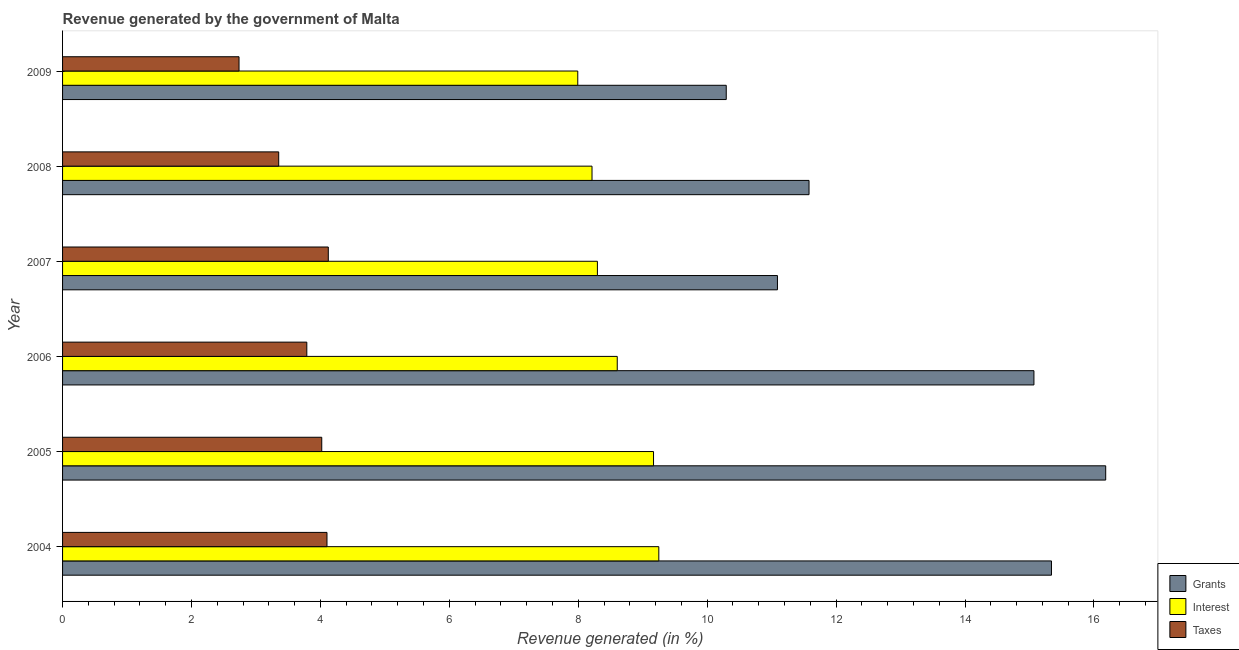How many different coloured bars are there?
Keep it short and to the point. 3. How many groups of bars are there?
Your response must be concise. 6. How many bars are there on the 4th tick from the bottom?
Offer a very short reply. 3. What is the percentage of revenue generated by grants in 2008?
Give a very brief answer. 11.58. Across all years, what is the maximum percentage of revenue generated by grants?
Keep it short and to the point. 16.18. Across all years, what is the minimum percentage of revenue generated by taxes?
Your response must be concise. 2.74. In which year was the percentage of revenue generated by taxes maximum?
Your answer should be compact. 2007. In which year was the percentage of revenue generated by grants minimum?
Your response must be concise. 2009. What is the total percentage of revenue generated by interest in the graph?
Offer a terse response. 51.53. What is the difference between the percentage of revenue generated by interest in 2005 and that in 2006?
Keep it short and to the point. 0.56. What is the difference between the percentage of revenue generated by grants in 2007 and the percentage of revenue generated by taxes in 2004?
Your answer should be compact. 6.99. What is the average percentage of revenue generated by grants per year?
Your answer should be very brief. 13.26. In the year 2006, what is the difference between the percentage of revenue generated by taxes and percentage of revenue generated by interest?
Make the answer very short. -4.82. What is the ratio of the percentage of revenue generated by grants in 2004 to that in 2008?
Your answer should be very brief. 1.32. What is the difference between the highest and the second highest percentage of revenue generated by interest?
Offer a very short reply. 0.08. What is the difference between the highest and the lowest percentage of revenue generated by taxes?
Your answer should be compact. 1.38. In how many years, is the percentage of revenue generated by interest greater than the average percentage of revenue generated by interest taken over all years?
Your response must be concise. 3. Is the sum of the percentage of revenue generated by interest in 2007 and 2008 greater than the maximum percentage of revenue generated by taxes across all years?
Your response must be concise. Yes. What does the 3rd bar from the top in 2005 represents?
Make the answer very short. Grants. What does the 1st bar from the bottom in 2006 represents?
Offer a very short reply. Grants. How many bars are there?
Your response must be concise. 18. Are all the bars in the graph horizontal?
Provide a short and direct response. Yes. Does the graph contain any zero values?
Offer a very short reply. No. What is the title of the graph?
Offer a very short reply. Revenue generated by the government of Malta. Does "Argument" appear as one of the legend labels in the graph?
Your response must be concise. No. What is the label or title of the X-axis?
Ensure brevity in your answer.  Revenue generated (in %). What is the label or title of the Y-axis?
Give a very brief answer. Year. What is the Revenue generated (in %) in Grants in 2004?
Give a very brief answer. 15.34. What is the Revenue generated (in %) of Interest in 2004?
Keep it short and to the point. 9.25. What is the Revenue generated (in %) of Taxes in 2004?
Provide a short and direct response. 4.1. What is the Revenue generated (in %) in Grants in 2005?
Offer a terse response. 16.18. What is the Revenue generated (in %) of Interest in 2005?
Your answer should be compact. 9.17. What is the Revenue generated (in %) of Taxes in 2005?
Offer a very short reply. 4.02. What is the Revenue generated (in %) of Grants in 2006?
Your answer should be compact. 15.07. What is the Revenue generated (in %) of Interest in 2006?
Your response must be concise. 8.6. What is the Revenue generated (in %) of Taxes in 2006?
Your answer should be very brief. 3.79. What is the Revenue generated (in %) of Grants in 2007?
Your response must be concise. 11.09. What is the Revenue generated (in %) in Interest in 2007?
Make the answer very short. 8.3. What is the Revenue generated (in %) in Taxes in 2007?
Keep it short and to the point. 4.12. What is the Revenue generated (in %) of Grants in 2008?
Your response must be concise. 11.58. What is the Revenue generated (in %) of Interest in 2008?
Provide a succinct answer. 8.21. What is the Revenue generated (in %) of Taxes in 2008?
Provide a succinct answer. 3.35. What is the Revenue generated (in %) of Grants in 2009?
Keep it short and to the point. 10.3. What is the Revenue generated (in %) in Interest in 2009?
Make the answer very short. 7.99. What is the Revenue generated (in %) in Taxes in 2009?
Make the answer very short. 2.74. Across all years, what is the maximum Revenue generated (in %) in Grants?
Provide a short and direct response. 16.18. Across all years, what is the maximum Revenue generated (in %) of Interest?
Provide a succinct answer. 9.25. Across all years, what is the maximum Revenue generated (in %) of Taxes?
Ensure brevity in your answer.  4.12. Across all years, what is the minimum Revenue generated (in %) of Grants?
Offer a very short reply. 10.3. Across all years, what is the minimum Revenue generated (in %) of Interest?
Ensure brevity in your answer.  7.99. Across all years, what is the minimum Revenue generated (in %) in Taxes?
Offer a very short reply. 2.74. What is the total Revenue generated (in %) in Grants in the graph?
Offer a very short reply. 79.56. What is the total Revenue generated (in %) in Interest in the graph?
Make the answer very short. 51.53. What is the total Revenue generated (in %) of Taxes in the graph?
Provide a short and direct response. 22.12. What is the difference between the Revenue generated (in %) in Grants in 2004 and that in 2005?
Your response must be concise. -0.84. What is the difference between the Revenue generated (in %) of Interest in 2004 and that in 2005?
Provide a short and direct response. 0.08. What is the difference between the Revenue generated (in %) in Taxes in 2004 and that in 2005?
Your answer should be compact. 0.08. What is the difference between the Revenue generated (in %) in Grants in 2004 and that in 2006?
Provide a succinct answer. 0.27. What is the difference between the Revenue generated (in %) of Interest in 2004 and that in 2006?
Ensure brevity in your answer.  0.64. What is the difference between the Revenue generated (in %) in Taxes in 2004 and that in 2006?
Offer a very short reply. 0.31. What is the difference between the Revenue generated (in %) of Grants in 2004 and that in 2007?
Make the answer very short. 4.25. What is the difference between the Revenue generated (in %) of Interest in 2004 and that in 2007?
Offer a terse response. 0.95. What is the difference between the Revenue generated (in %) of Taxes in 2004 and that in 2007?
Give a very brief answer. -0.02. What is the difference between the Revenue generated (in %) in Grants in 2004 and that in 2008?
Offer a terse response. 3.76. What is the difference between the Revenue generated (in %) of Interest in 2004 and that in 2008?
Your answer should be compact. 1.04. What is the difference between the Revenue generated (in %) of Taxes in 2004 and that in 2008?
Your response must be concise. 0.75. What is the difference between the Revenue generated (in %) of Grants in 2004 and that in 2009?
Provide a short and direct response. 5.05. What is the difference between the Revenue generated (in %) of Interest in 2004 and that in 2009?
Provide a succinct answer. 1.26. What is the difference between the Revenue generated (in %) in Taxes in 2004 and that in 2009?
Make the answer very short. 1.36. What is the difference between the Revenue generated (in %) of Grants in 2005 and that in 2006?
Offer a very short reply. 1.11. What is the difference between the Revenue generated (in %) in Interest in 2005 and that in 2006?
Your answer should be compact. 0.56. What is the difference between the Revenue generated (in %) of Taxes in 2005 and that in 2006?
Keep it short and to the point. 0.23. What is the difference between the Revenue generated (in %) in Grants in 2005 and that in 2007?
Give a very brief answer. 5.09. What is the difference between the Revenue generated (in %) in Interest in 2005 and that in 2007?
Offer a very short reply. 0.87. What is the difference between the Revenue generated (in %) of Taxes in 2005 and that in 2007?
Your response must be concise. -0.1. What is the difference between the Revenue generated (in %) of Grants in 2005 and that in 2008?
Give a very brief answer. 4.6. What is the difference between the Revenue generated (in %) in Interest in 2005 and that in 2008?
Your answer should be compact. 0.95. What is the difference between the Revenue generated (in %) in Taxes in 2005 and that in 2008?
Give a very brief answer. 0.67. What is the difference between the Revenue generated (in %) of Grants in 2005 and that in 2009?
Make the answer very short. 5.89. What is the difference between the Revenue generated (in %) in Interest in 2005 and that in 2009?
Your response must be concise. 1.18. What is the difference between the Revenue generated (in %) in Taxes in 2005 and that in 2009?
Give a very brief answer. 1.28. What is the difference between the Revenue generated (in %) of Grants in 2006 and that in 2007?
Provide a succinct answer. 3.98. What is the difference between the Revenue generated (in %) of Interest in 2006 and that in 2007?
Your answer should be compact. 0.31. What is the difference between the Revenue generated (in %) of Taxes in 2006 and that in 2007?
Give a very brief answer. -0.33. What is the difference between the Revenue generated (in %) in Grants in 2006 and that in 2008?
Ensure brevity in your answer.  3.49. What is the difference between the Revenue generated (in %) in Interest in 2006 and that in 2008?
Your response must be concise. 0.39. What is the difference between the Revenue generated (in %) of Taxes in 2006 and that in 2008?
Provide a succinct answer. 0.44. What is the difference between the Revenue generated (in %) of Grants in 2006 and that in 2009?
Make the answer very short. 4.77. What is the difference between the Revenue generated (in %) in Interest in 2006 and that in 2009?
Make the answer very short. 0.61. What is the difference between the Revenue generated (in %) in Taxes in 2006 and that in 2009?
Keep it short and to the point. 1.05. What is the difference between the Revenue generated (in %) in Grants in 2007 and that in 2008?
Your response must be concise. -0.49. What is the difference between the Revenue generated (in %) in Interest in 2007 and that in 2008?
Provide a succinct answer. 0.08. What is the difference between the Revenue generated (in %) of Taxes in 2007 and that in 2008?
Ensure brevity in your answer.  0.77. What is the difference between the Revenue generated (in %) in Grants in 2007 and that in 2009?
Your response must be concise. 0.79. What is the difference between the Revenue generated (in %) in Interest in 2007 and that in 2009?
Keep it short and to the point. 0.3. What is the difference between the Revenue generated (in %) in Taxes in 2007 and that in 2009?
Make the answer very short. 1.38. What is the difference between the Revenue generated (in %) in Grants in 2008 and that in 2009?
Ensure brevity in your answer.  1.28. What is the difference between the Revenue generated (in %) in Interest in 2008 and that in 2009?
Offer a very short reply. 0.22. What is the difference between the Revenue generated (in %) in Taxes in 2008 and that in 2009?
Make the answer very short. 0.62. What is the difference between the Revenue generated (in %) in Grants in 2004 and the Revenue generated (in %) in Interest in 2005?
Your answer should be very brief. 6.17. What is the difference between the Revenue generated (in %) in Grants in 2004 and the Revenue generated (in %) in Taxes in 2005?
Make the answer very short. 11.32. What is the difference between the Revenue generated (in %) in Interest in 2004 and the Revenue generated (in %) in Taxes in 2005?
Offer a terse response. 5.23. What is the difference between the Revenue generated (in %) in Grants in 2004 and the Revenue generated (in %) in Interest in 2006?
Your answer should be very brief. 6.74. What is the difference between the Revenue generated (in %) of Grants in 2004 and the Revenue generated (in %) of Taxes in 2006?
Make the answer very short. 11.55. What is the difference between the Revenue generated (in %) of Interest in 2004 and the Revenue generated (in %) of Taxes in 2006?
Your answer should be compact. 5.46. What is the difference between the Revenue generated (in %) in Grants in 2004 and the Revenue generated (in %) in Interest in 2007?
Make the answer very short. 7.04. What is the difference between the Revenue generated (in %) of Grants in 2004 and the Revenue generated (in %) of Taxes in 2007?
Your answer should be compact. 11.22. What is the difference between the Revenue generated (in %) of Interest in 2004 and the Revenue generated (in %) of Taxes in 2007?
Provide a succinct answer. 5.13. What is the difference between the Revenue generated (in %) in Grants in 2004 and the Revenue generated (in %) in Interest in 2008?
Offer a very short reply. 7.13. What is the difference between the Revenue generated (in %) in Grants in 2004 and the Revenue generated (in %) in Taxes in 2008?
Offer a very short reply. 11.99. What is the difference between the Revenue generated (in %) of Interest in 2004 and the Revenue generated (in %) of Taxes in 2008?
Provide a short and direct response. 5.9. What is the difference between the Revenue generated (in %) of Grants in 2004 and the Revenue generated (in %) of Interest in 2009?
Your answer should be very brief. 7.35. What is the difference between the Revenue generated (in %) in Grants in 2004 and the Revenue generated (in %) in Taxes in 2009?
Provide a short and direct response. 12.6. What is the difference between the Revenue generated (in %) of Interest in 2004 and the Revenue generated (in %) of Taxes in 2009?
Ensure brevity in your answer.  6.51. What is the difference between the Revenue generated (in %) of Grants in 2005 and the Revenue generated (in %) of Interest in 2006?
Give a very brief answer. 7.58. What is the difference between the Revenue generated (in %) of Grants in 2005 and the Revenue generated (in %) of Taxes in 2006?
Your answer should be very brief. 12.39. What is the difference between the Revenue generated (in %) of Interest in 2005 and the Revenue generated (in %) of Taxes in 2006?
Offer a terse response. 5.38. What is the difference between the Revenue generated (in %) of Grants in 2005 and the Revenue generated (in %) of Interest in 2007?
Offer a terse response. 7.89. What is the difference between the Revenue generated (in %) of Grants in 2005 and the Revenue generated (in %) of Taxes in 2007?
Give a very brief answer. 12.06. What is the difference between the Revenue generated (in %) of Interest in 2005 and the Revenue generated (in %) of Taxes in 2007?
Your answer should be compact. 5.05. What is the difference between the Revenue generated (in %) of Grants in 2005 and the Revenue generated (in %) of Interest in 2008?
Offer a terse response. 7.97. What is the difference between the Revenue generated (in %) in Grants in 2005 and the Revenue generated (in %) in Taxes in 2008?
Your response must be concise. 12.83. What is the difference between the Revenue generated (in %) of Interest in 2005 and the Revenue generated (in %) of Taxes in 2008?
Offer a terse response. 5.81. What is the difference between the Revenue generated (in %) in Grants in 2005 and the Revenue generated (in %) in Interest in 2009?
Give a very brief answer. 8.19. What is the difference between the Revenue generated (in %) in Grants in 2005 and the Revenue generated (in %) in Taxes in 2009?
Provide a succinct answer. 13.45. What is the difference between the Revenue generated (in %) of Interest in 2005 and the Revenue generated (in %) of Taxes in 2009?
Make the answer very short. 6.43. What is the difference between the Revenue generated (in %) of Grants in 2006 and the Revenue generated (in %) of Interest in 2007?
Provide a succinct answer. 6.77. What is the difference between the Revenue generated (in %) of Grants in 2006 and the Revenue generated (in %) of Taxes in 2007?
Make the answer very short. 10.95. What is the difference between the Revenue generated (in %) of Interest in 2006 and the Revenue generated (in %) of Taxes in 2007?
Your response must be concise. 4.48. What is the difference between the Revenue generated (in %) of Grants in 2006 and the Revenue generated (in %) of Interest in 2008?
Ensure brevity in your answer.  6.86. What is the difference between the Revenue generated (in %) of Grants in 2006 and the Revenue generated (in %) of Taxes in 2008?
Your answer should be very brief. 11.72. What is the difference between the Revenue generated (in %) in Interest in 2006 and the Revenue generated (in %) in Taxes in 2008?
Your response must be concise. 5.25. What is the difference between the Revenue generated (in %) in Grants in 2006 and the Revenue generated (in %) in Interest in 2009?
Offer a terse response. 7.08. What is the difference between the Revenue generated (in %) in Grants in 2006 and the Revenue generated (in %) in Taxes in 2009?
Ensure brevity in your answer.  12.33. What is the difference between the Revenue generated (in %) of Interest in 2006 and the Revenue generated (in %) of Taxes in 2009?
Your answer should be compact. 5.87. What is the difference between the Revenue generated (in %) in Grants in 2007 and the Revenue generated (in %) in Interest in 2008?
Offer a terse response. 2.88. What is the difference between the Revenue generated (in %) of Grants in 2007 and the Revenue generated (in %) of Taxes in 2008?
Your answer should be compact. 7.74. What is the difference between the Revenue generated (in %) of Interest in 2007 and the Revenue generated (in %) of Taxes in 2008?
Ensure brevity in your answer.  4.94. What is the difference between the Revenue generated (in %) in Grants in 2007 and the Revenue generated (in %) in Interest in 2009?
Make the answer very short. 3.1. What is the difference between the Revenue generated (in %) in Grants in 2007 and the Revenue generated (in %) in Taxes in 2009?
Give a very brief answer. 8.35. What is the difference between the Revenue generated (in %) in Interest in 2007 and the Revenue generated (in %) in Taxes in 2009?
Your answer should be compact. 5.56. What is the difference between the Revenue generated (in %) in Grants in 2008 and the Revenue generated (in %) in Interest in 2009?
Provide a succinct answer. 3.59. What is the difference between the Revenue generated (in %) of Grants in 2008 and the Revenue generated (in %) of Taxes in 2009?
Your answer should be compact. 8.84. What is the difference between the Revenue generated (in %) of Interest in 2008 and the Revenue generated (in %) of Taxes in 2009?
Give a very brief answer. 5.48. What is the average Revenue generated (in %) in Grants per year?
Make the answer very short. 13.26. What is the average Revenue generated (in %) of Interest per year?
Ensure brevity in your answer.  8.59. What is the average Revenue generated (in %) of Taxes per year?
Provide a short and direct response. 3.69. In the year 2004, what is the difference between the Revenue generated (in %) in Grants and Revenue generated (in %) in Interest?
Give a very brief answer. 6.09. In the year 2004, what is the difference between the Revenue generated (in %) in Grants and Revenue generated (in %) in Taxes?
Your answer should be very brief. 11.24. In the year 2004, what is the difference between the Revenue generated (in %) of Interest and Revenue generated (in %) of Taxes?
Your response must be concise. 5.15. In the year 2005, what is the difference between the Revenue generated (in %) in Grants and Revenue generated (in %) in Interest?
Offer a very short reply. 7.01. In the year 2005, what is the difference between the Revenue generated (in %) of Grants and Revenue generated (in %) of Taxes?
Keep it short and to the point. 12.16. In the year 2005, what is the difference between the Revenue generated (in %) of Interest and Revenue generated (in %) of Taxes?
Provide a short and direct response. 5.15. In the year 2006, what is the difference between the Revenue generated (in %) of Grants and Revenue generated (in %) of Interest?
Provide a succinct answer. 6.46. In the year 2006, what is the difference between the Revenue generated (in %) of Grants and Revenue generated (in %) of Taxes?
Give a very brief answer. 11.28. In the year 2006, what is the difference between the Revenue generated (in %) in Interest and Revenue generated (in %) in Taxes?
Ensure brevity in your answer.  4.82. In the year 2007, what is the difference between the Revenue generated (in %) of Grants and Revenue generated (in %) of Interest?
Give a very brief answer. 2.79. In the year 2007, what is the difference between the Revenue generated (in %) of Grants and Revenue generated (in %) of Taxes?
Give a very brief answer. 6.97. In the year 2007, what is the difference between the Revenue generated (in %) of Interest and Revenue generated (in %) of Taxes?
Keep it short and to the point. 4.17. In the year 2008, what is the difference between the Revenue generated (in %) of Grants and Revenue generated (in %) of Interest?
Provide a succinct answer. 3.37. In the year 2008, what is the difference between the Revenue generated (in %) of Grants and Revenue generated (in %) of Taxes?
Offer a very short reply. 8.23. In the year 2008, what is the difference between the Revenue generated (in %) of Interest and Revenue generated (in %) of Taxes?
Give a very brief answer. 4.86. In the year 2009, what is the difference between the Revenue generated (in %) of Grants and Revenue generated (in %) of Interest?
Give a very brief answer. 2.3. In the year 2009, what is the difference between the Revenue generated (in %) of Grants and Revenue generated (in %) of Taxes?
Offer a very short reply. 7.56. In the year 2009, what is the difference between the Revenue generated (in %) of Interest and Revenue generated (in %) of Taxes?
Your response must be concise. 5.25. What is the ratio of the Revenue generated (in %) of Grants in 2004 to that in 2005?
Keep it short and to the point. 0.95. What is the ratio of the Revenue generated (in %) of Interest in 2004 to that in 2005?
Offer a terse response. 1.01. What is the ratio of the Revenue generated (in %) of Taxes in 2004 to that in 2005?
Offer a terse response. 1.02. What is the ratio of the Revenue generated (in %) in Interest in 2004 to that in 2006?
Your answer should be very brief. 1.07. What is the ratio of the Revenue generated (in %) in Taxes in 2004 to that in 2006?
Your response must be concise. 1.08. What is the ratio of the Revenue generated (in %) of Grants in 2004 to that in 2007?
Provide a succinct answer. 1.38. What is the ratio of the Revenue generated (in %) in Interest in 2004 to that in 2007?
Offer a very short reply. 1.11. What is the ratio of the Revenue generated (in %) in Grants in 2004 to that in 2008?
Provide a succinct answer. 1.32. What is the ratio of the Revenue generated (in %) in Interest in 2004 to that in 2008?
Offer a very short reply. 1.13. What is the ratio of the Revenue generated (in %) in Taxes in 2004 to that in 2008?
Give a very brief answer. 1.22. What is the ratio of the Revenue generated (in %) in Grants in 2004 to that in 2009?
Keep it short and to the point. 1.49. What is the ratio of the Revenue generated (in %) in Interest in 2004 to that in 2009?
Provide a succinct answer. 1.16. What is the ratio of the Revenue generated (in %) of Taxes in 2004 to that in 2009?
Offer a terse response. 1.5. What is the ratio of the Revenue generated (in %) in Grants in 2005 to that in 2006?
Ensure brevity in your answer.  1.07. What is the ratio of the Revenue generated (in %) of Interest in 2005 to that in 2006?
Offer a terse response. 1.07. What is the ratio of the Revenue generated (in %) in Taxes in 2005 to that in 2006?
Provide a short and direct response. 1.06. What is the ratio of the Revenue generated (in %) of Grants in 2005 to that in 2007?
Ensure brevity in your answer.  1.46. What is the ratio of the Revenue generated (in %) in Interest in 2005 to that in 2007?
Keep it short and to the point. 1.1. What is the ratio of the Revenue generated (in %) of Taxes in 2005 to that in 2007?
Offer a very short reply. 0.98. What is the ratio of the Revenue generated (in %) of Grants in 2005 to that in 2008?
Your response must be concise. 1.4. What is the ratio of the Revenue generated (in %) of Interest in 2005 to that in 2008?
Provide a succinct answer. 1.12. What is the ratio of the Revenue generated (in %) of Taxes in 2005 to that in 2008?
Make the answer very short. 1.2. What is the ratio of the Revenue generated (in %) in Grants in 2005 to that in 2009?
Provide a succinct answer. 1.57. What is the ratio of the Revenue generated (in %) of Interest in 2005 to that in 2009?
Make the answer very short. 1.15. What is the ratio of the Revenue generated (in %) of Taxes in 2005 to that in 2009?
Provide a succinct answer. 1.47. What is the ratio of the Revenue generated (in %) in Grants in 2006 to that in 2007?
Make the answer very short. 1.36. What is the ratio of the Revenue generated (in %) in Interest in 2006 to that in 2007?
Ensure brevity in your answer.  1.04. What is the ratio of the Revenue generated (in %) of Taxes in 2006 to that in 2007?
Provide a succinct answer. 0.92. What is the ratio of the Revenue generated (in %) of Grants in 2006 to that in 2008?
Offer a terse response. 1.3. What is the ratio of the Revenue generated (in %) of Interest in 2006 to that in 2008?
Keep it short and to the point. 1.05. What is the ratio of the Revenue generated (in %) in Taxes in 2006 to that in 2008?
Offer a very short reply. 1.13. What is the ratio of the Revenue generated (in %) of Grants in 2006 to that in 2009?
Provide a short and direct response. 1.46. What is the ratio of the Revenue generated (in %) of Interest in 2006 to that in 2009?
Your answer should be compact. 1.08. What is the ratio of the Revenue generated (in %) of Taxes in 2006 to that in 2009?
Provide a succinct answer. 1.38. What is the ratio of the Revenue generated (in %) in Grants in 2007 to that in 2008?
Keep it short and to the point. 0.96. What is the ratio of the Revenue generated (in %) of Interest in 2007 to that in 2008?
Keep it short and to the point. 1.01. What is the ratio of the Revenue generated (in %) in Taxes in 2007 to that in 2008?
Ensure brevity in your answer.  1.23. What is the ratio of the Revenue generated (in %) of Grants in 2007 to that in 2009?
Provide a succinct answer. 1.08. What is the ratio of the Revenue generated (in %) in Interest in 2007 to that in 2009?
Your response must be concise. 1.04. What is the ratio of the Revenue generated (in %) in Taxes in 2007 to that in 2009?
Provide a short and direct response. 1.51. What is the ratio of the Revenue generated (in %) in Grants in 2008 to that in 2009?
Your response must be concise. 1.12. What is the ratio of the Revenue generated (in %) of Interest in 2008 to that in 2009?
Your answer should be compact. 1.03. What is the ratio of the Revenue generated (in %) in Taxes in 2008 to that in 2009?
Give a very brief answer. 1.22. What is the difference between the highest and the second highest Revenue generated (in %) in Grants?
Provide a short and direct response. 0.84. What is the difference between the highest and the second highest Revenue generated (in %) of Interest?
Keep it short and to the point. 0.08. What is the difference between the highest and the second highest Revenue generated (in %) of Taxes?
Keep it short and to the point. 0.02. What is the difference between the highest and the lowest Revenue generated (in %) in Grants?
Keep it short and to the point. 5.89. What is the difference between the highest and the lowest Revenue generated (in %) of Interest?
Provide a succinct answer. 1.26. What is the difference between the highest and the lowest Revenue generated (in %) in Taxes?
Keep it short and to the point. 1.38. 